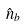<formula> <loc_0><loc_0><loc_500><loc_500>\hat { n } _ { b }</formula> 